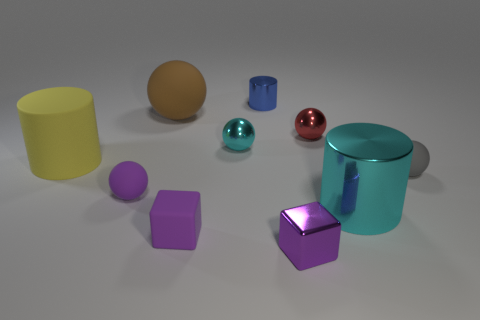Subtract all red spheres. How many spheres are left? 4 Subtract all small purple balls. How many balls are left? 4 Subtract all cyan spheres. Subtract all cyan blocks. How many spheres are left? 4 Subtract all cubes. How many objects are left? 8 Add 5 shiny balls. How many shiny balls are left? 7 Add 1 small metal cylinders. How many small metal cylinders exist? 2 Subtract 0 blue blocks. How many objects are left? 10 Subtract all yellow rubber blocks. Subtract all small gray rubber spheres. How many objects are left? 9 